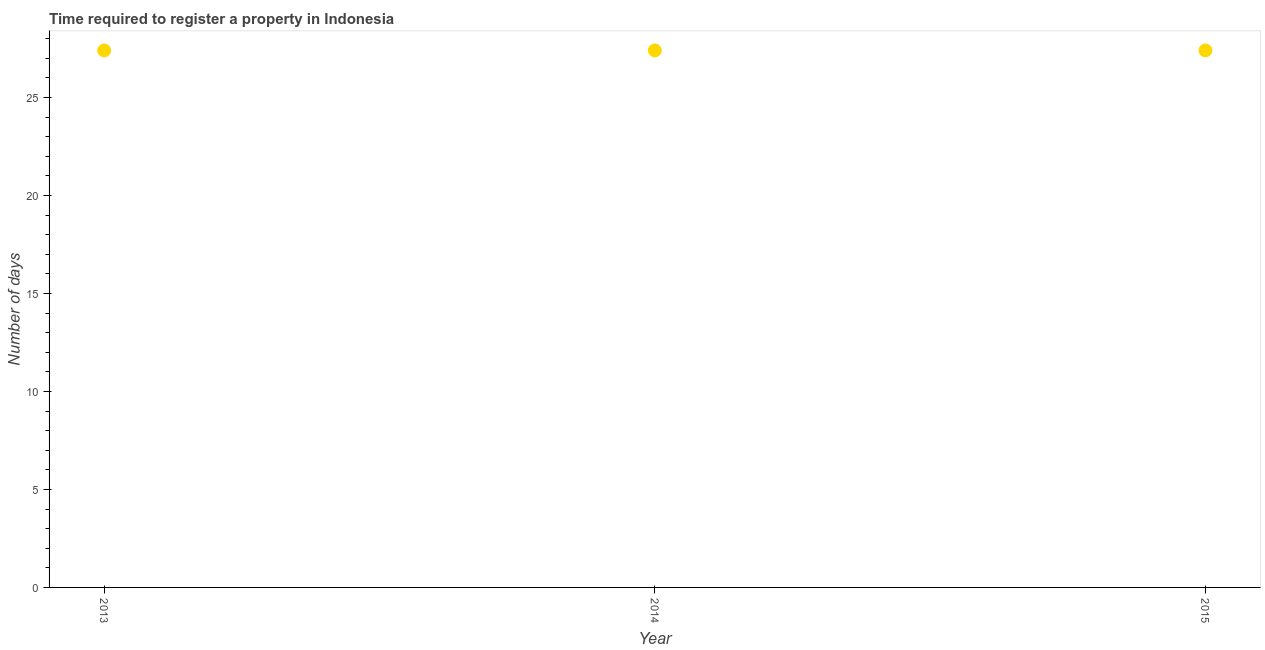What is the number of days required to register property in 2015?
Keep it short and to the point. 27.4. Across all years, what is the maximum number of days required to register property?
Keep it short and to the point. 27.4. Across all years, what is the minimum number of days required to register property?
Make the answer very short. 27.4. In which year was the number of days required to register property minimum?
Provide a succinct answer. 2013. What is the sum of the number of days required to register property?
Give a very brief answer. 82.2. What is the difference between the number of days required to register property in 2013 and 2014?
Provide a succinct answer. 0. What is the average number of days required to register property per year?
Ensure brevity in your answer.  27.4. What is the median number of days required to register property?
Give a very brief answer. 27.4. What is the ratio of the number of days required to register property in 2013 to that in 2015?
Provide a short and direct response. 1. Is the number of days required to register property in 2013 less than that in 2015?
Provide a succinct answer. No. Is the difference between the number of days required to register property in 2013 and 2015 greater than the difference between any two years?
Your response must be concise. Yes. In how many years, is the number of days required to register property greater than the average number of days required to register property taken over all years?
Keep it short and to the point. 3. Are the values on the major ticks of Y-axis written in scientific E-notation?
Give a very brief answer. No. Does the graph contain grids?
Offer a terse response. No. What is the title of the graph?
Keep it short and to the point. Time required to register a property in Indonesia. What is the label or title of the X-axis?
Keep it short and to the point. Year. What is the label or title of the Y-axis?
Offer a very short reply. Number of days. What is the Number of days in 2013?
Make the answer very short. 27.4. What is the Number of days in 2014?
Provide a succinct answer. 27.4. What is the Number of days in 2015?
Ensure brevity in your answer.  27.4. What is the difference between the Number of days in 2013 and 2014?
Make the answer very short. 0. What is the ratio of the Number of days in 2013 to that in 2014?
Keep it short and to the point. 1. What is the ratio of the Number of days in 2013 to that in 2015?
Your response must be concise. 1. 